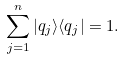<formula> <loc_0><loc_0><loc_500><loc_500>\sum _ { j = 1 } ^ { n } | q _ { j } \rangle \langle q _ { j } | = { 1 } .</formula> 